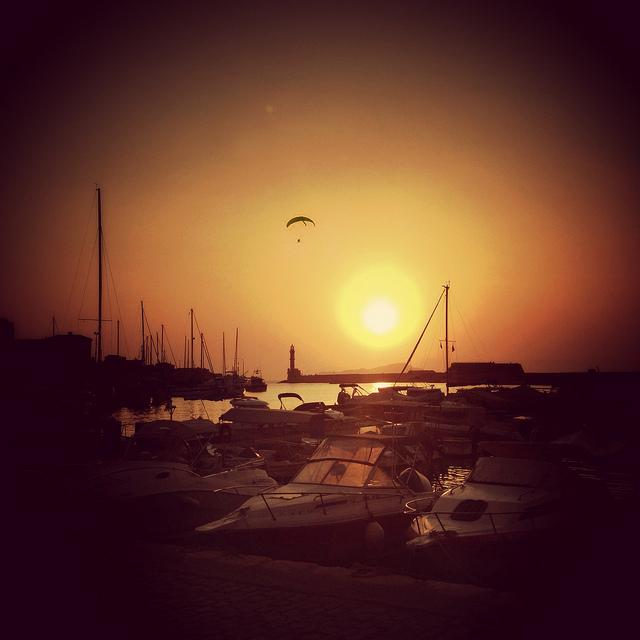This scene is likely to appear where?

Choices:
A) babysitter resume
B) photographers portfolio
C) dog advertisement
D) wanted ad photographers portfolio 